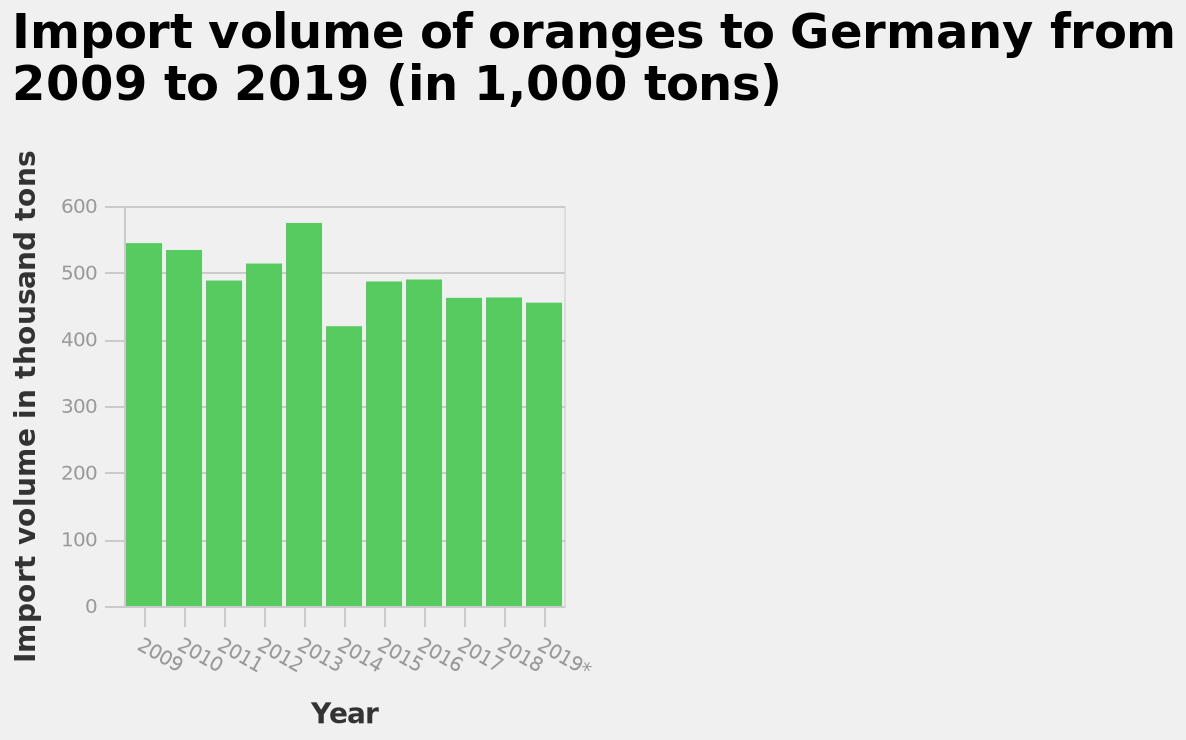<image>
Did the import volume of oranges increase or decrease after 2013? The information provided does not give any indication of the import volume of oranges after 2013. please describe the details of the chart Import volume of oranges to Germany from 2009 to 2019 (in 1,000 tons) is a bar plot. A linear scale from 0 to 600 can be found along the y-axis, labeled Import volume in thousand tons. Year is drawn on the x-axis. please summary the statistics and relations of the chart The import volume of oranges dropped from 2009 to 2011 with import volumes then increasing in the subsequent 2 years. 2014 saw the import volume drop by 100 thousand tonnes and then subsequently the import volume has stayed very similar. 